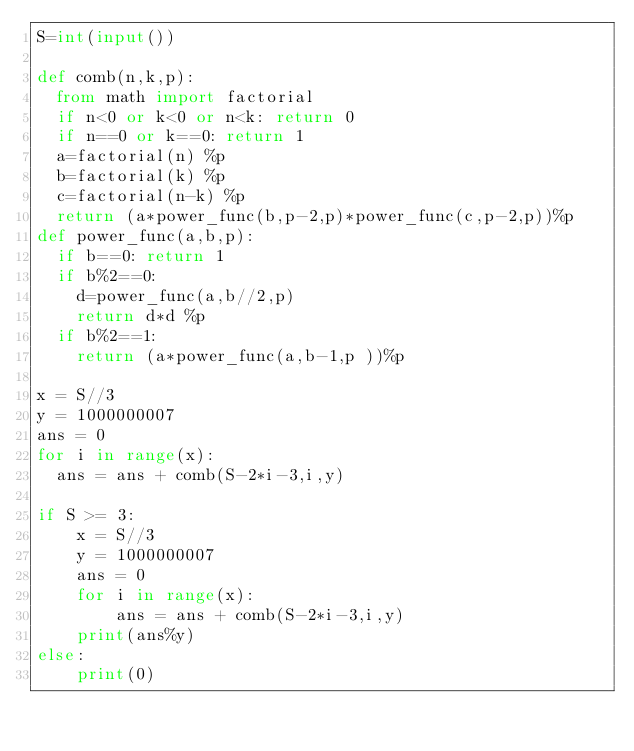<code> <loc_0><loc_0><loc_500><loc_500><_Python_>S=int(input())

def comb(n,k,p):
  from math import factorial
  if n<0 or k<0 or n<k: return 0
  if n==0 or k==0: return 1
  a=factorial(n) %p
  b=factorial(k) %p
  c=factorial(n-k) %p
  return (a*power_func(b,p-2,p)*power_func(c,p-2,p))%p
def power_func(a,b,p):
  if b==0: return 1
  if b%2==0:
    d=power_func(a,b//2,p)
    return d*d %p
  if b%2==1:
    return (a*power_func(a,b-1,p ))%p
  
x = S//3
y = 1000000007
ans = 0
for i in range(x):
  ans = ans + comb(S-2*i-3,i,y)
  
if S >= 3:
    x = S//3
    y = 1000000007
    ans = 0
    for i in range(x):
        ans = ans + comb(S-2*i-3,i,y)
    print(ans%y)
else:
    print(0)</code> 